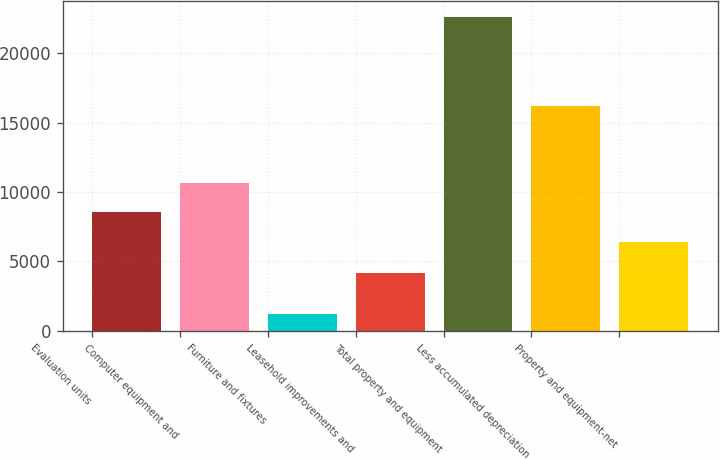<chart> <loc_0><loc_0><loc_500><loc_500><bar_chart><fcel>Evaluation units<fcel>Computer equipment and<fcel>Furniture and fixtures<fcel>Leasehold improvements and<fcel>Total property and equipment<fcel>Less accumulated depreciation<fcel>Property and equipment-net<nl><fcel>8528<fcel>10669<fcel>1191<fcel>4134<fcel>22601<fcel>16214<fcel>6387<nl></chart> 